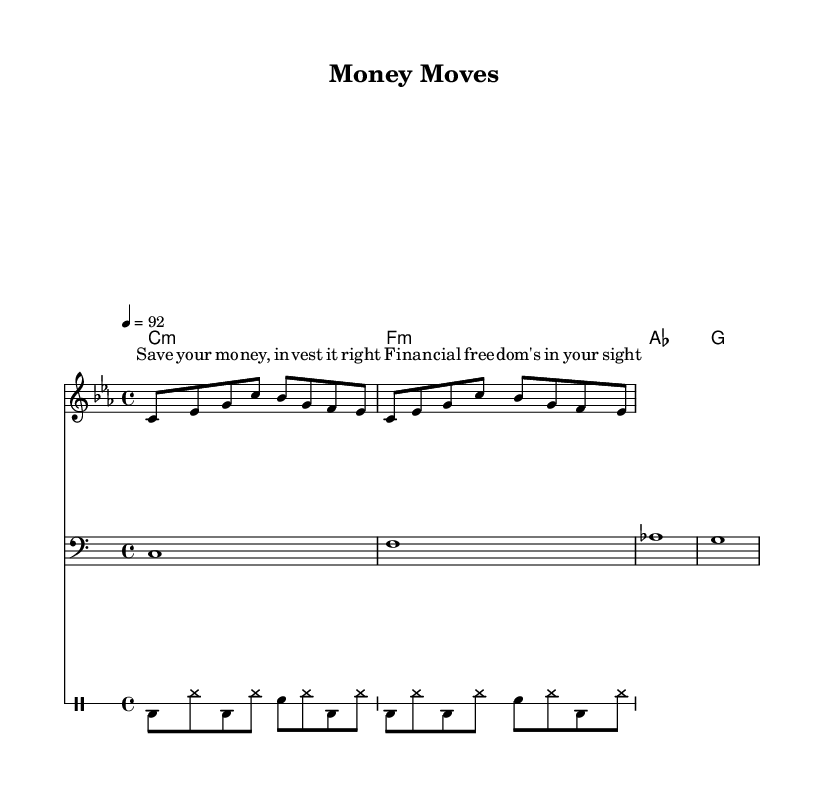What is the key signature of this music? The key signature is C minor, which has three flats (B, E, and A). This can be determined by looking at the key signature indicated at the beginning of the sheet music.
Answer: C minor What is the time signature of this piece? The time signature is 4/4, which can be found in the beginning section of the sheet music right after the key signature. It indicates there are four beats in each measure.
Answer: 4/4 What is the tempo marking of the music? The tempo marking is 92 beats per minute, indicated by the tempo directive "4 = 92" at the beginning of the score. This tells the performer the speed at which to play the music.
Answer: 92 How many measures are included in the melody section? The melody section contains 2 measures as indicated by the notation and the specific pattern of the melody notes. Each measure is separated by a vertical line, making it easy to count them.
Answer: 2 What type of song is described by the lyrics? The lyrics focus on financial freedom, which aligns with a motivational theme commonly found in hip-hop that emphasizes self-improvement and wealth-building. This theme is evident in the message of saving and investing money.
Answer: Motivational What kind of drum pattern is used in the piece? The drum pattern comprises a kick (bd), hi-hat (hh), and snare (sn) in a repetitive sequence, characteristic of hip-hop rhythms, providing a steady groove throughout the piece.
Answer: Repetitive kick and hi-hat pattern What is the main theme presented in the lyrics? The main theme presented in the lyrics is about saving and investing money for financial freedom, which is a central concept in motivational rap songs aimed at building wealth.
Answer: Financial freedom 